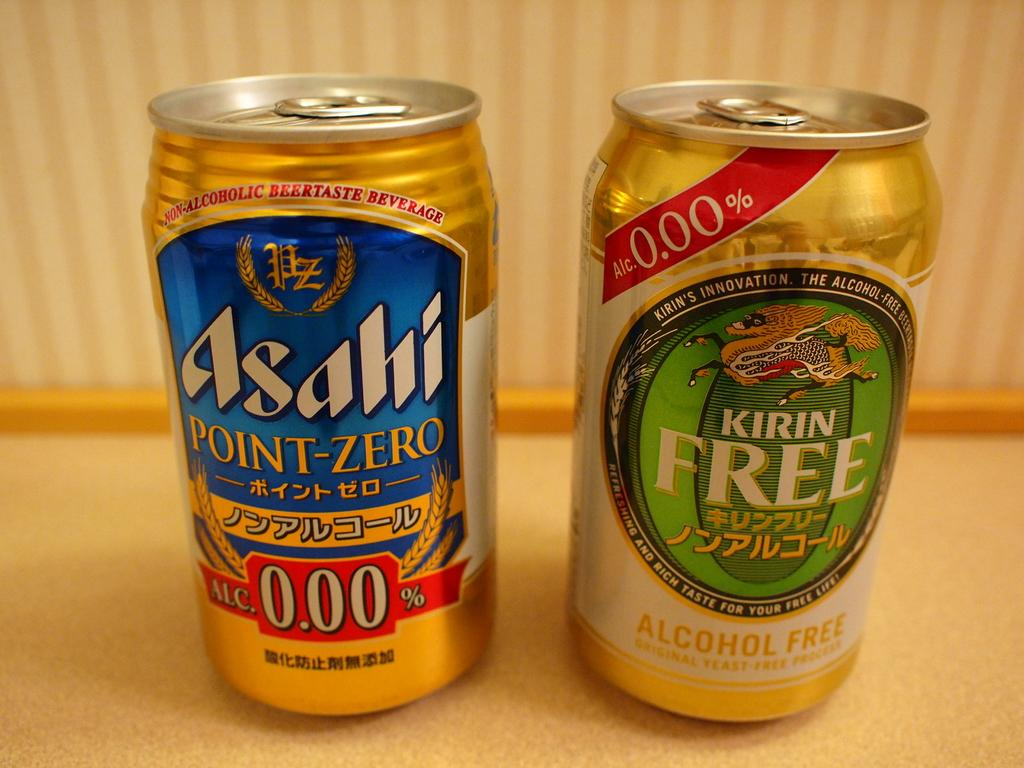<image>
Summarize the visual content of the image. A can of Asahi and a can of Kirin are standing next to each other. 